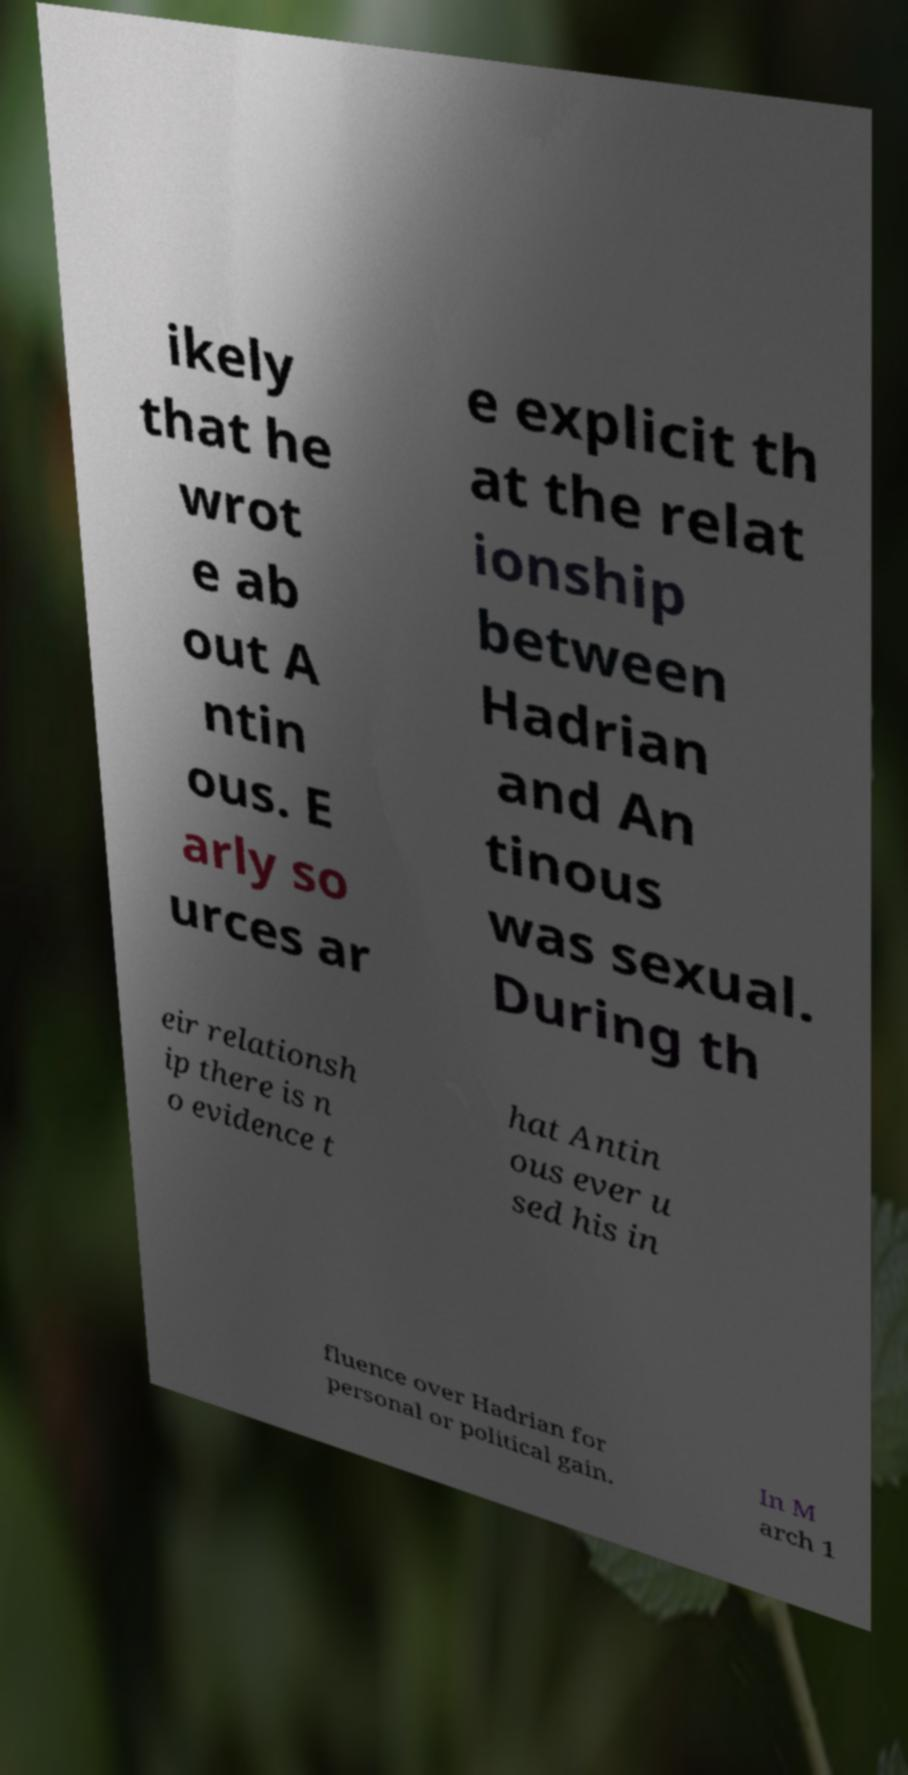What messages or text are displayed in this image? I need them in a readable, typed format. ikely that he wrot e ab out A ntin ous. E arly so urces ar e explicit th at the relat ionship between Hadrian and An tinous was sexual. During th eir relationsh ip there is n o evidence t hat Antin ous ever u sed his in fluence over Hadrian for personal or political gain. In M arch 1 